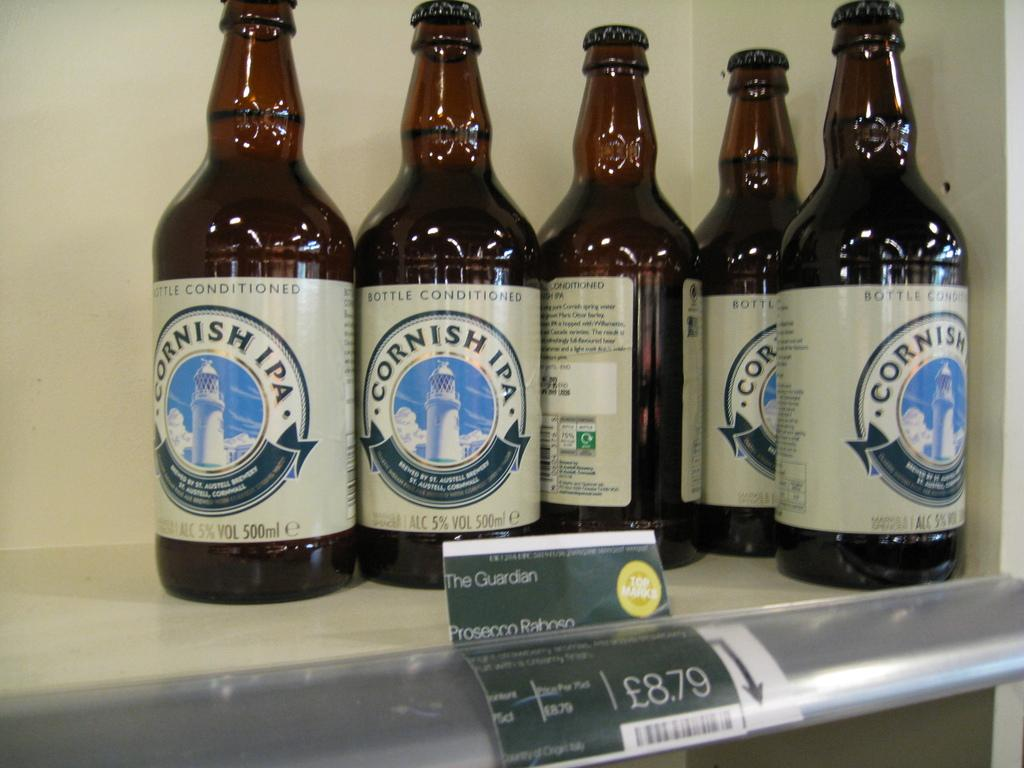<image>
Give a short and clear explanation of the subsequent image. five bottles on a store shelf of Cornish IPA Beer. 